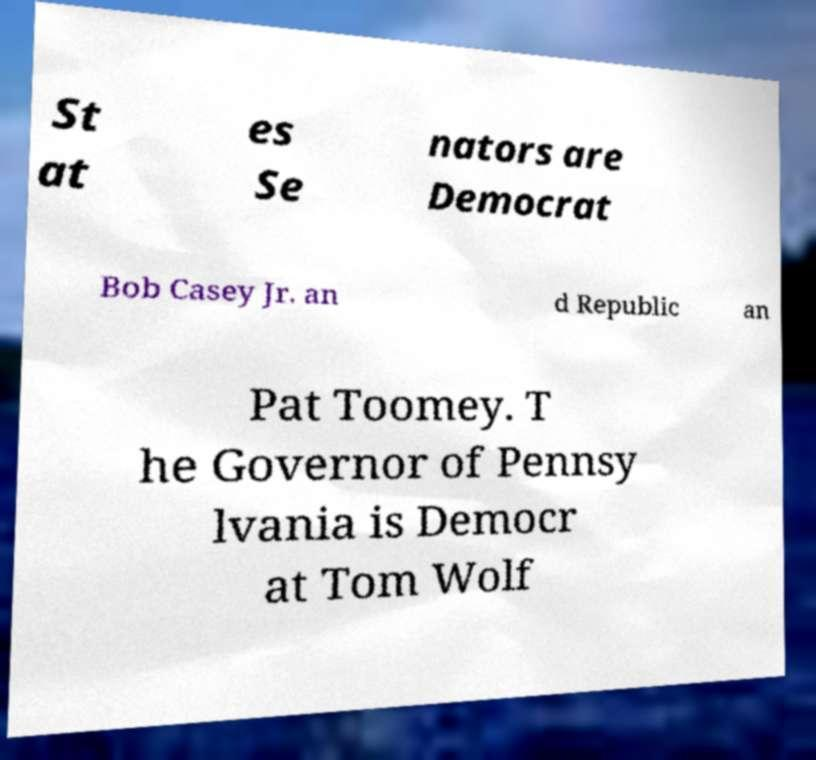There's text embedded in this image that I need extracted. Can you transcribe it verbatim? St at es Se nators are Democrat Bob Casey Jr. an d Republic an Pat Toomey. T he Governor of Pennsy lvania is Democr at Tom Wolf 